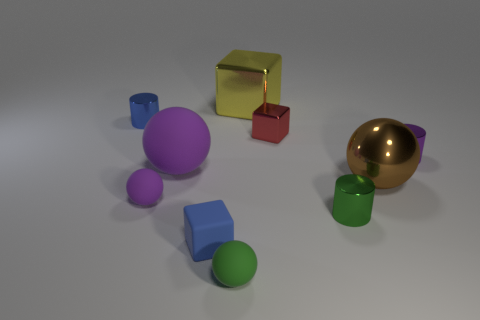Subtract all tiny purple matte balls. How many balls are left? 3 Subtract all green balls. How many balls are left? 3 Subtract 1 spheres. How many spheres are left? 3 Subtract all cylinders. How many objects are left? 7 Subtract all cyan cylinders. Subtract all purple blocks. How many cylinders are left? 3 Subtract all gray spheres. How many green cubes are left? 0 Subtract all red shiny cylinders. Subtract all big yellow blocks. How many objects are left? 9 Add 7 blue metal objects. How many blue metal objects are left? 8 Add 1 green objects. How many green objects exist? 3 Subtract 0 red cylinders. How many objects are left? 10 